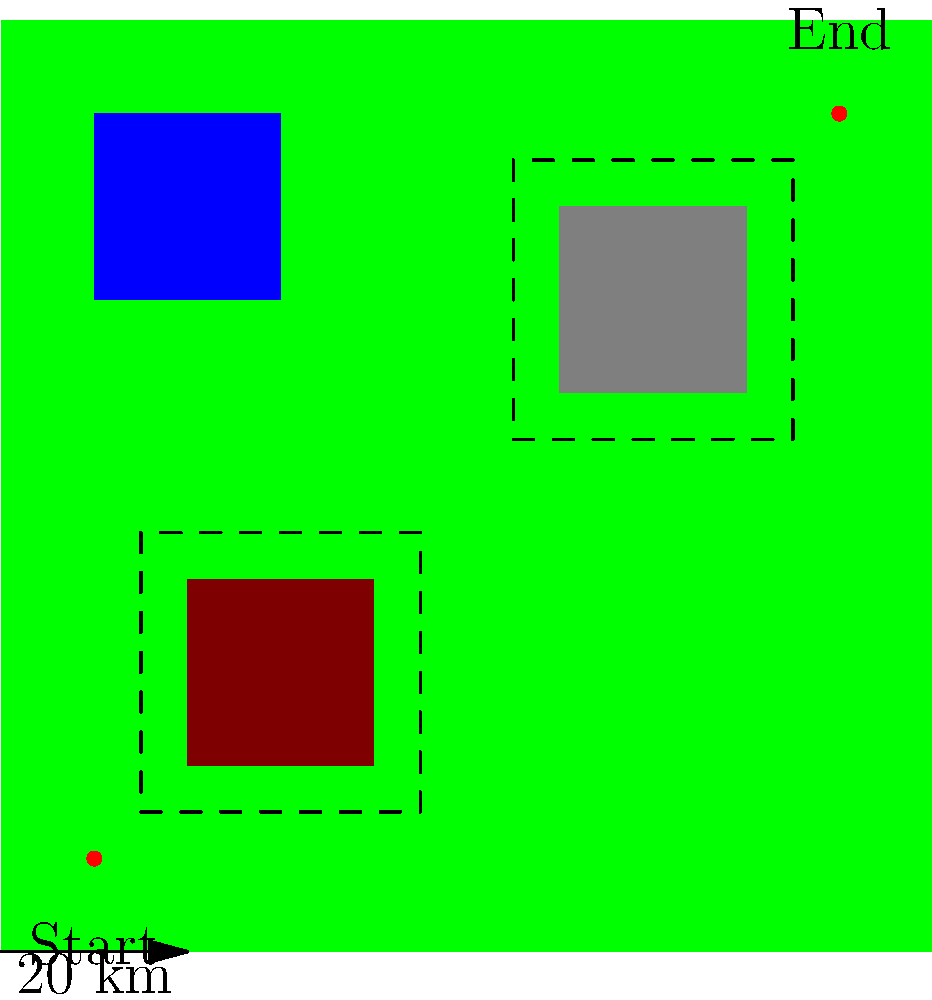Based on the topographical map provided, what is the most efficient route for a military convoy to travel from the Start point to the End point, considering the terrain types and their impact on vehicle speed and fuel consumption? To determine the most efficient route, we need to consider the following factors:

1. Terrain types:
   - Plains (green): Easiest to traverse, highest speed, lowest fuel consumption
   - Hills (brown): Moderate difficulty, reduced speed, increased fuel consumption
   - Mountains (gray): Most difficult, lowest speed, highest fuel consumption
   - Water (blue): Impassable for ground vehicles

2. Distance: The straight-line distance is not always the most efficient due to terrain obstacles.

3. Contour lines: Closely spaced contour lines indicate steep terrain (hills or mountains).

Step-by-step analysis:
1. The start point (10,10) is in the plains, offering an easy initial path.
2. Moving northeast, we encounter a hilly region (20,20 to 40,40).
3. There's a water body (10,70 to 30,90) that must be avoided.
4. The mountainous region (60,60 to 80,80) presents the most challenging terrain.
5. The end point (90,90) is in the plains, offering an easy final approach.

Optimal route:
1. Start at (10,10) and head east through the plains.
2. Skirt the southern edge of the hilly region, staying in the plains.
3. Continue east, then gradually turn northeast, maintaining a path through the plains.
4. Pass between the water body and the mountainous region, utilizing the plains.
5. Approach the end point (90,90) from the south, avoiding the mountains.

This route maximizes travel through plains, minimizes hill traversal, completely avoids mountains and water, and maintains a relatively direct path to the destination. It balances the need for speed, fuel efficiency, and overall distance traveled.
Answer: Eastward through plains, skirting hills southerly, then northeast between water and mountains 